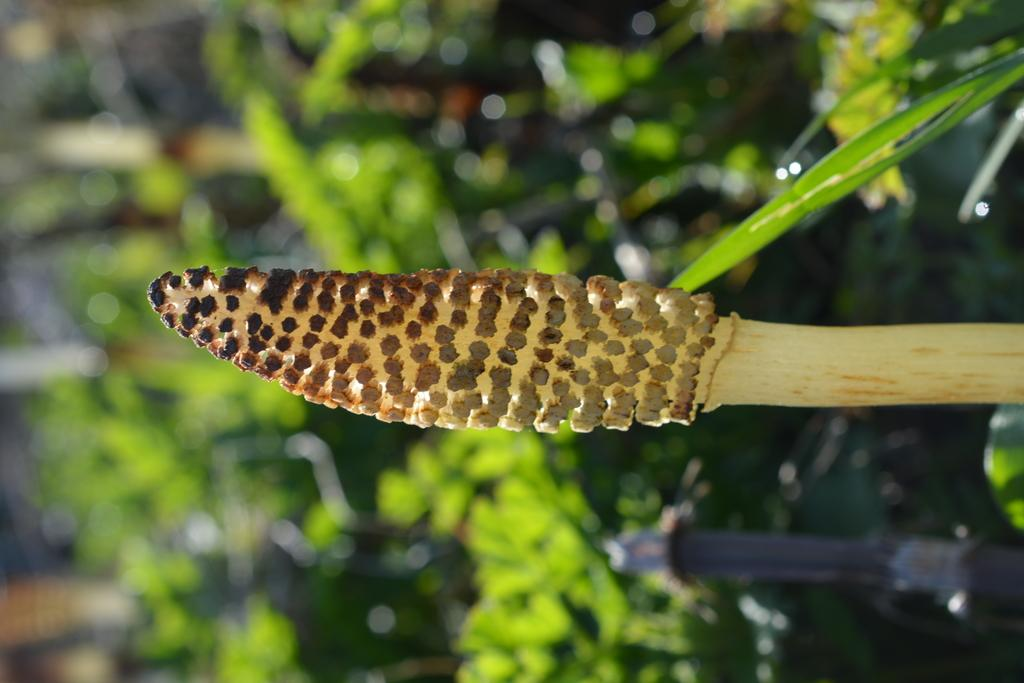What colors can be seen on the main object in the image? The main object in the image has cream, brown, and black colors. What is visible in the background of the image? The background of the image contains multiple plants. How would you describe the appearance of the background? The background appears blurred. What type of office equipment can be seen in the image? There is no office equipment present in the image. What kind of toy is visible in the image? There is no toy present in the image. 